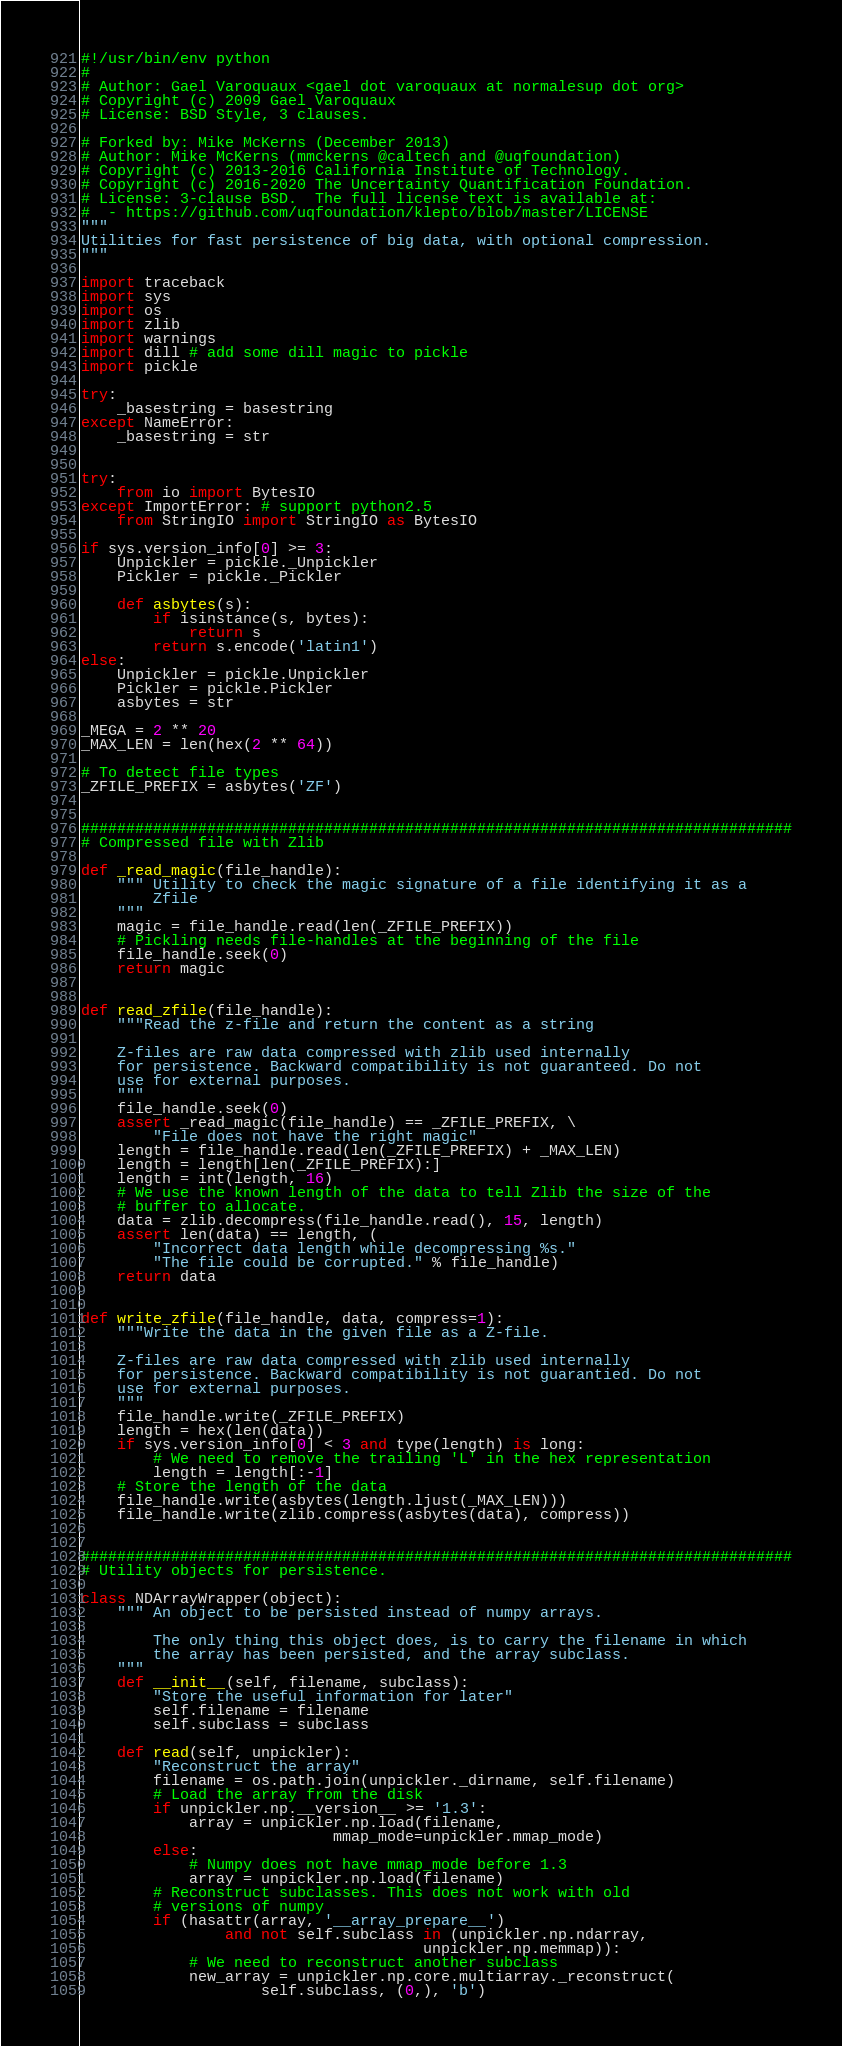Convert code to text. <code><loc_0><loc_0><loc_500><loc_500><_Python_>#!/usr/bin/env python
#
# Author: Gael Varoquaux <gael dot varoquaux at normalesup dot org>
# Copyright (c) 2009 Gael Varoquaux
# License: BSD Style, 3 clauses.

# Forked by: Mike McKerns (December 2013)
# Author: Mike McKerns (mmckerns @caltech and @uqfoundation)
# Copyright (c) 2013-2016 California Institute of Technology.
# Copyright (c) 2016-2020 The Uncertainty Quantification Foundation.
# License: 3-clause BSD.  The full license text is available at:
#  - https://github.com/uqfoundation/klepto/blob/master/LICENSE
"""
Utilities for fast persistence of big data, with optional compression.
"""

import traceback
import sys
import os
import zlib
import warnings
import dill # add some dill magic to pickle
import pickle

try:
    _basestring = basestring
except NameError:
    _basestring = str


try:
    from io import BytesIO
except ImportError: # support python2.5
    from StringIO import StringIO as BytesIO

if sys.version_info[0] >= 3:
    Unpickler = pickle._Unpickler
    Pickler = pickle._Pickler

    def asbytes(s):
        if isinstance(s, bytes):
            return s
        return s.encode('latin1')
else:
    Unpickler = pickle.Unpickler
    Pickler = pickle.Pickler
    asbytes = str

_MEGA = 2 ** 20
_MAX_LEN = len(hex(2 ** 64))

# To detect file types
_ZFILE_PREFIX = asbytes('ZF')


###############################################################################
# Compressed file with Zlib

def _read_magic(file_handle):
    """ Utility to check the magic signature of a file identifying it as a
        Zfile
    """
    magic = file_handle.read(len(_ZFILE_PREFIX))
    # Pickling needs file-handles at the beginning of the file
    file_handle.seek(0)
    return magic


def read_zfile(file_handle):
    """Read the z-file and return the content as a string

    Z-files are raw data compressed with zlib used internally
    for persistence. Backward compatibility is not guaranteed. Do not
    use for external purposes.
    """
    file_handle.seek(0)
    assert _read_magic(file_handle) == _ZFILE_PREFIX, \
        "File does not have the right magic"
    length = file_handle.read(len(_ZFILE_PREFIX) + _MAX_LEN)
    length = length[len(_ZFILE_PREFIX):]
    length = int(length, 16)
    # We use the known length of the data to tell Zlib the size of the
    # buffer to allocate.
    data = zlib.decompress(file_handle.read(), 15, length)
    assert len(data) == length, (
        "Incorrect data length while decompressing %s."
        "The file could be corrupted." % file_handle)
    return data


def write_zfile(file_handle, data, compress=1):
    """Write the data in the given file as a Z-file.

    Z-files are raw data compressed with zlib used internally
    for persistence. Backward compatibility is not guarantied. Do not
    use for external purposes.
    """
    file_handle.write(_ZFILE_PREFIX)
    length = hex(len(data))
    if sys.version_info[0] < 3 and type(length) is long:
        # We need to remove the trailing 'L' in the hex representation
        length = length[:-1]
    # Store the length of the data
    file_handle.write(asbytes(length.ljust(_MAX_LEN)))
    file_handle.write(zlib.compress(asbytes(data), compress))


###############################################################################
# Utility objects for persistence.

class NDArrayWrapper(object):
    """ An object to be persisted instead of numpy arrays.

        The only thing this object does, is to carry the filename in which
        the array has been persisted, and the array subclass.
    """
    def __init__(self, filename, subclass):
        "Store the useful information for later"
        self.filename = filename
        self.subclass = subclass

    def read(self, unpickler):
        "Reconstruct the array"
        filename = os.path.join(unpickler._dirname, self.filename)
        # Load the array from the disk
        if unpickler.np.__version__ >= '1.3':
            array = unpickler.np.load(filename,
                            mmap_mode=unpickler.mmap_mode)
        else:
            # Numpy does not have mmap_mode before 1.3
            array = unpickler.np.load(filename)
        # Reconstruct subclasses. This does not work with old
        # versions of numpy
        if (hasattr(array, '__array_prepare__')
                and not self.subclass in (unpickler.np.ndarray,
                                      unpickler.np.memmap)):
            # We need to reconstruct another subclass
            new_array = unpickler.np.core.multiarray._reconstruct(
                    self.subclass, (0,), 'b')</code> 